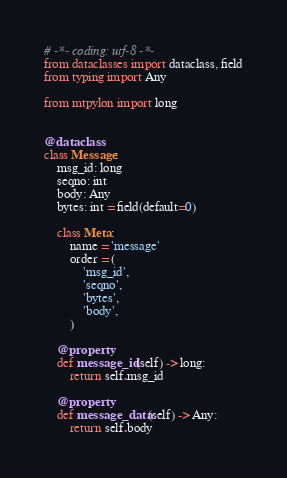Convert code to text. <code><loc_0><loc_0><loc_500><loc_500><_Python_># -*- coding: utf-8 -*-
from dataclasses import dataclass, field
from typing import Any

from mtpylon import long


@dataclass
class Message:
    msg_id: long
    seqno: int
    body: Any
    bytes: int = field(default=0)

    class Meta:
        name = 'message'
        order = (
            'msg_id',
            'seqno',
            'bytes',
            'body',
        )

    @property
    def message_id(self) -> long:
        return self.msg_id

    @property
    def message_data(self) -> Any:
        return self.body
</code> 